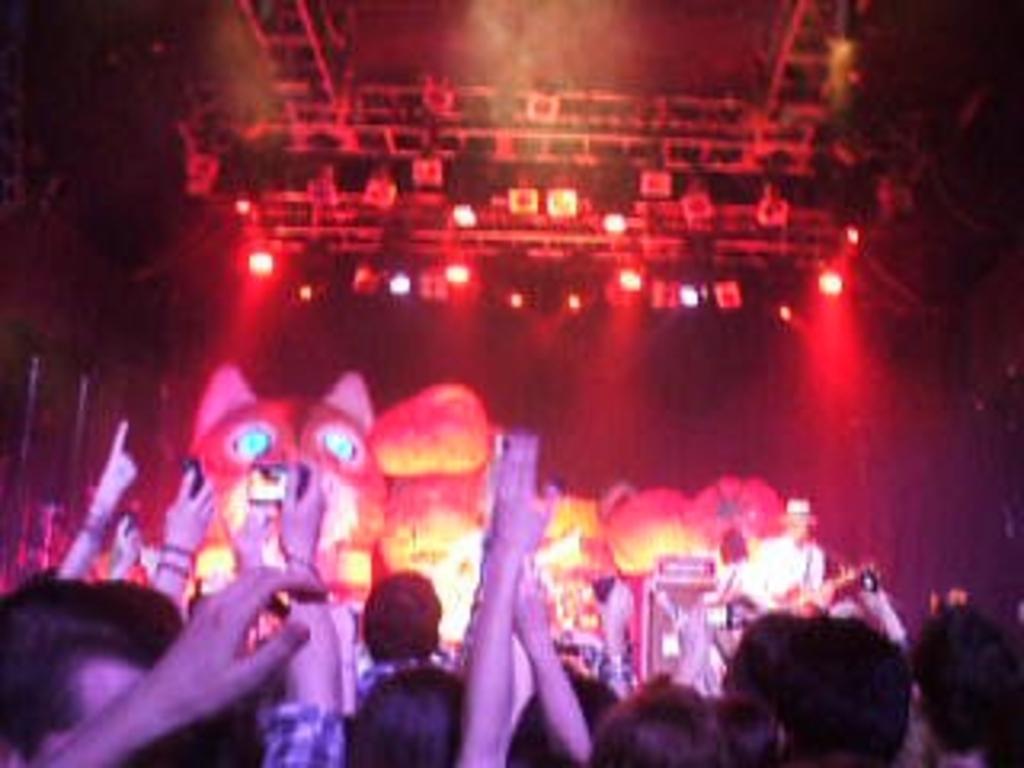Please provide a concise description of this image. In this image in front few people are standing on the floor by holding the cameras. In front of them there is a person playing musical instruments. Behind him there is a depiction of an animal. On top of the roof there are lights. 